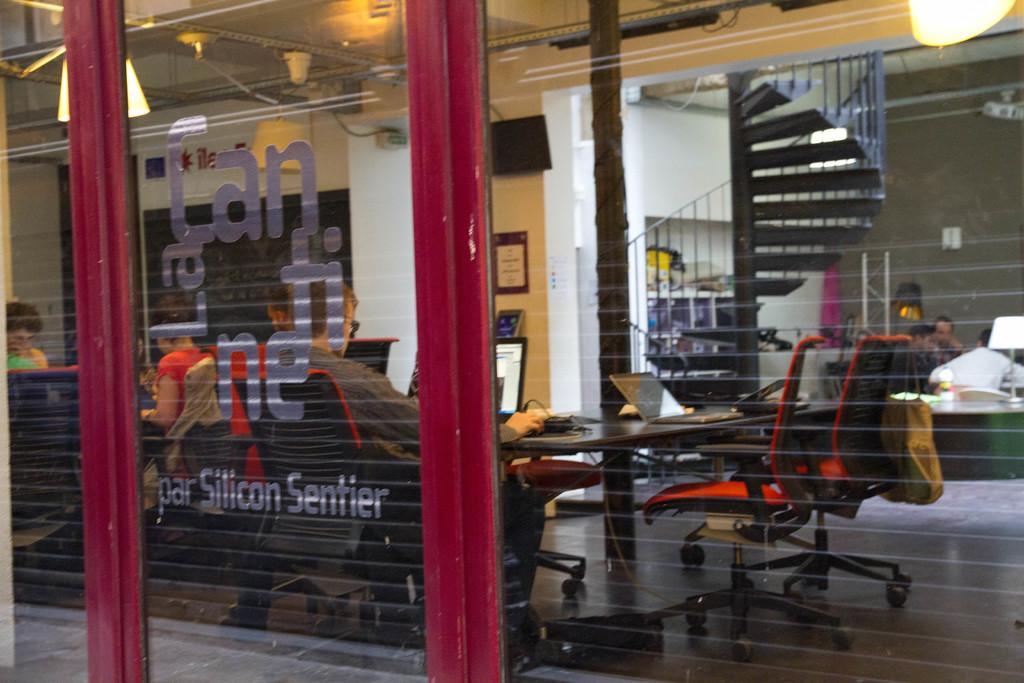Can you describe this image briefly? In this picture I can see a building in front and through the glasses I can see few people who are sitting on chairs and I see tables in front of them, on which there are laptops. On the top of this picture I can see the ceiling on which there are lights. In the background I can see the stairs and few more people. In the front of this picture I can see something is written on the glass. 